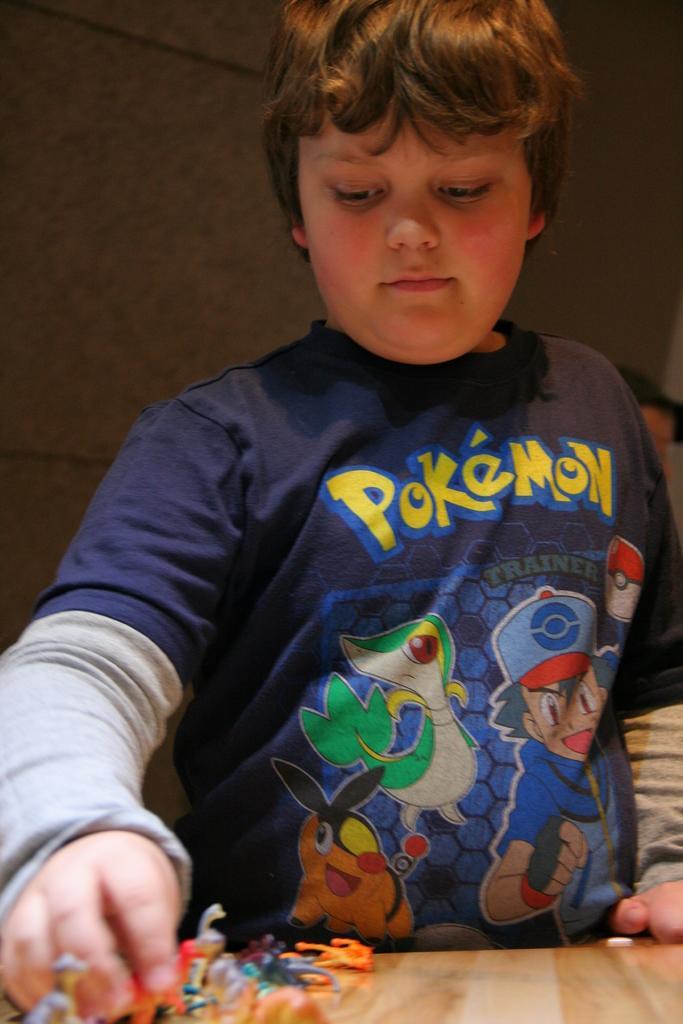Please provide a concise description of this image. In this picture we can see a kid in the front, at the bottom there is a table, we can see some toys on the table, in the background there is a wall. 